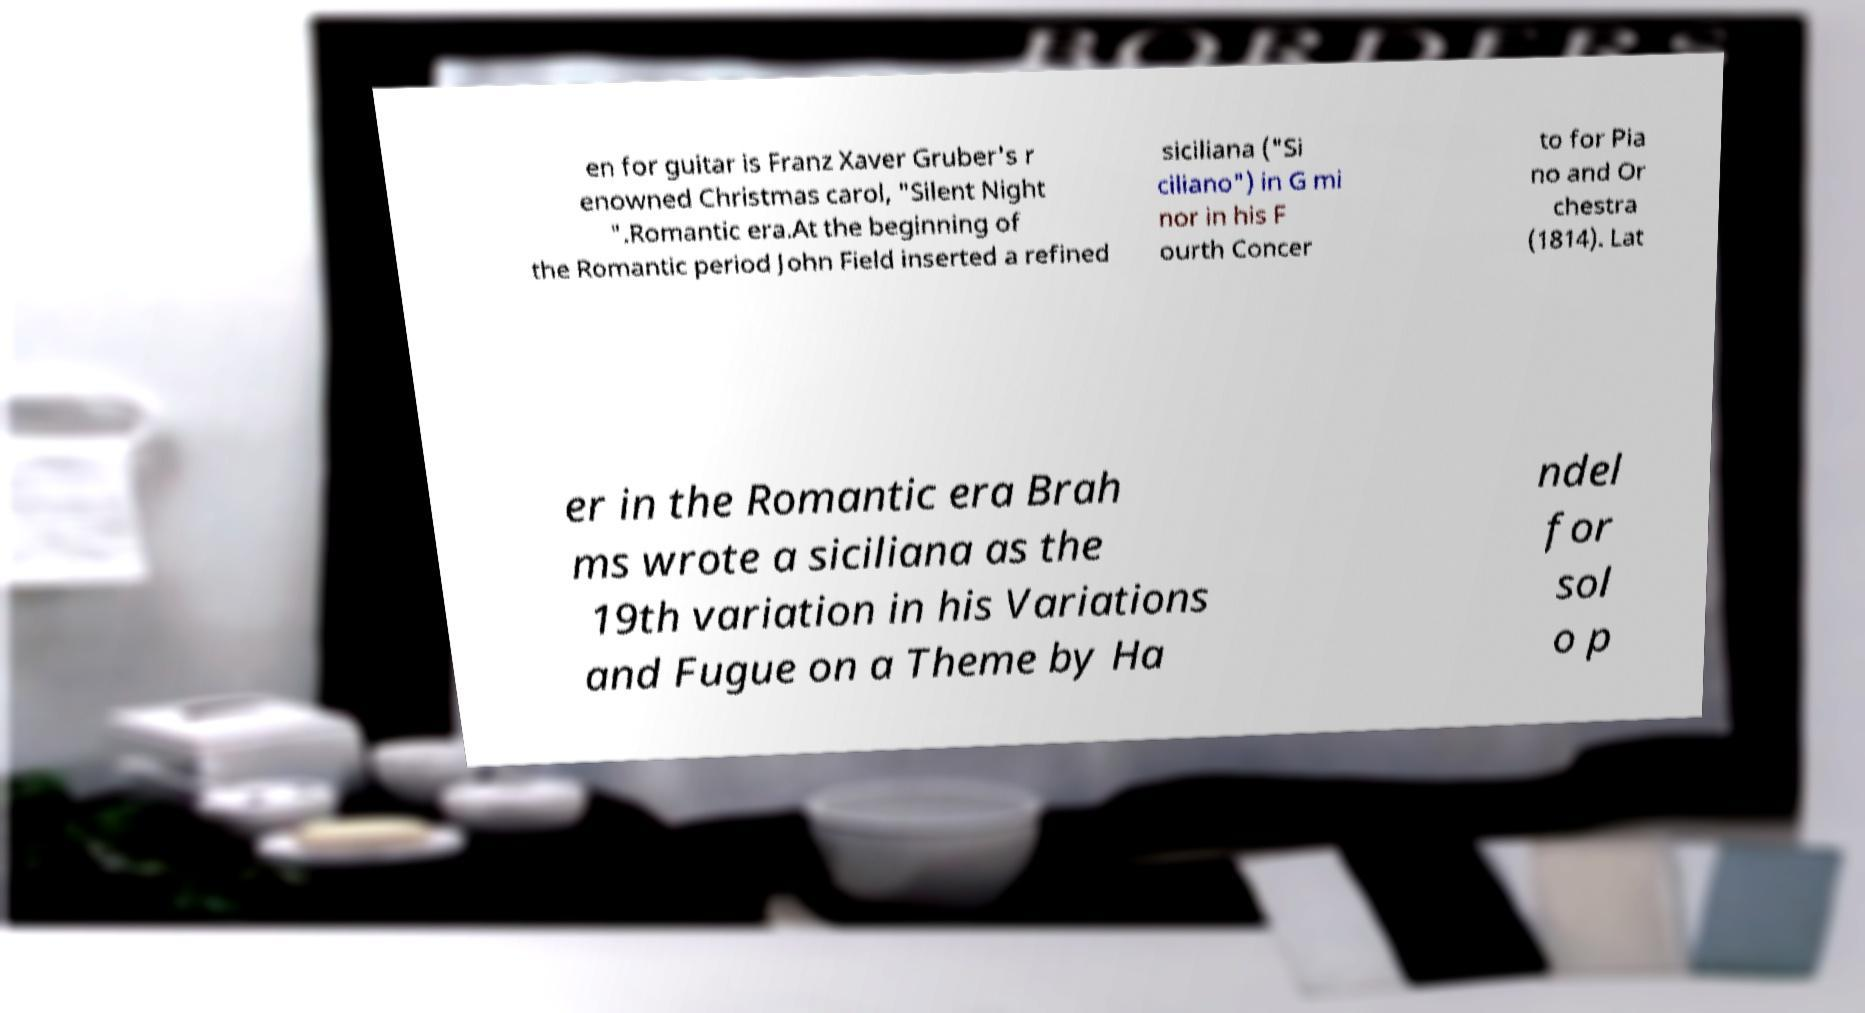Could you assist in decoding the text presented in this image and type it out clearly? en for guitar is Franz Xaver Gruber's r enowned Christmas carol, "Silent Night ".Romantic era.At the beginning of the Romantic period John Field inserted a refined siciliana ("Si ciliano") in G mi nor in his F ourth Concer to for Pia no and Or chestra (1814). Lat er in the Romantic era Brah ms wrote a siciliana as the 19th variation in his Variations and Fugue on a Theme by Ha ndel for sol o p 